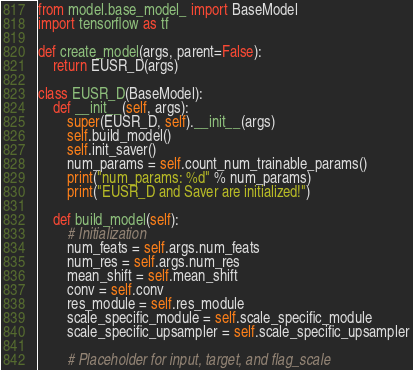<code> <loc_0><loc_0><loc_500><loc_500><_Python_>from model.base_model_ import BaseModel
import tensorflow as tf

def create_model(args, parent=False):
    return EUSR_D(args)

class EUSR_D(BaseModel):
	def __init__(self, args):
		super(EUSR_D, self).__init__(args)
		self.build_model()
		self.init_saver()
		num_params = self.count_num_trainable_params()
		print("num_params: %d" % num_params)
		print("EUSR_D and Saver are initialized!")

	def build_model(self):
		# Initialization
		num_feats = self.args.num_feats
		num_res = self.args.num_res
		mean_shift = self.mean_shift
		conv = self.conv
		res_module = self.res_module
		scale_specific_module = self.scale_specific_module
		scale_specific_upsampler = self.scale_specific_upsampler

		# Placeholder for input, target, and flag_scale</code> 